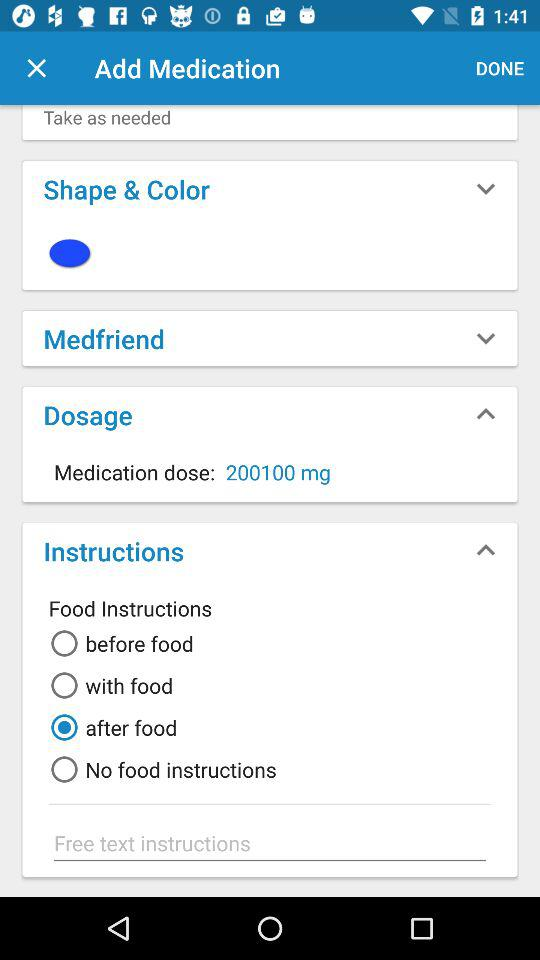Which option is selected for "Food Instructions"? The selected option for "Food Instructions" is "after food". 